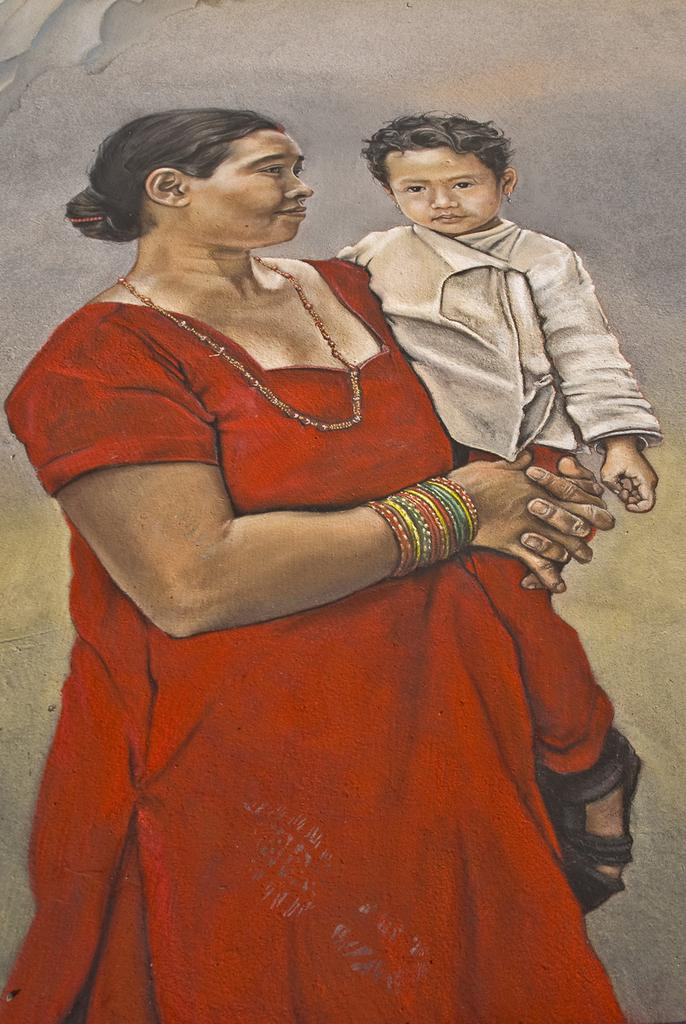What is the main subject of the image? There is a painting in the image. What is the painting depicting? The painting depicts a woman carrying a boy. What type of iron is the woman using to press the boy's clothes in the image? There is no iron present in the image; the painting depicts a woman carrying a boy. How many brothers does the boy have in the image? The image does not provide information about the boy's siblings, as it only depicts the woman carrying the boy. 